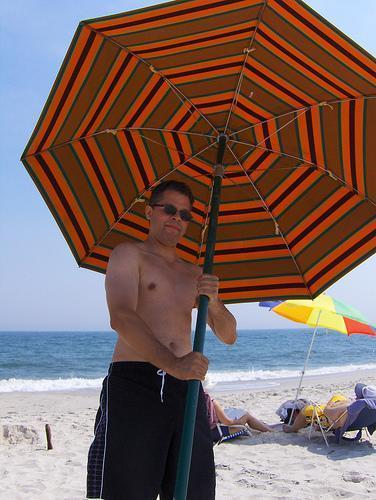How many people are holding umbrellas?
Give a very brief answer. 1. 